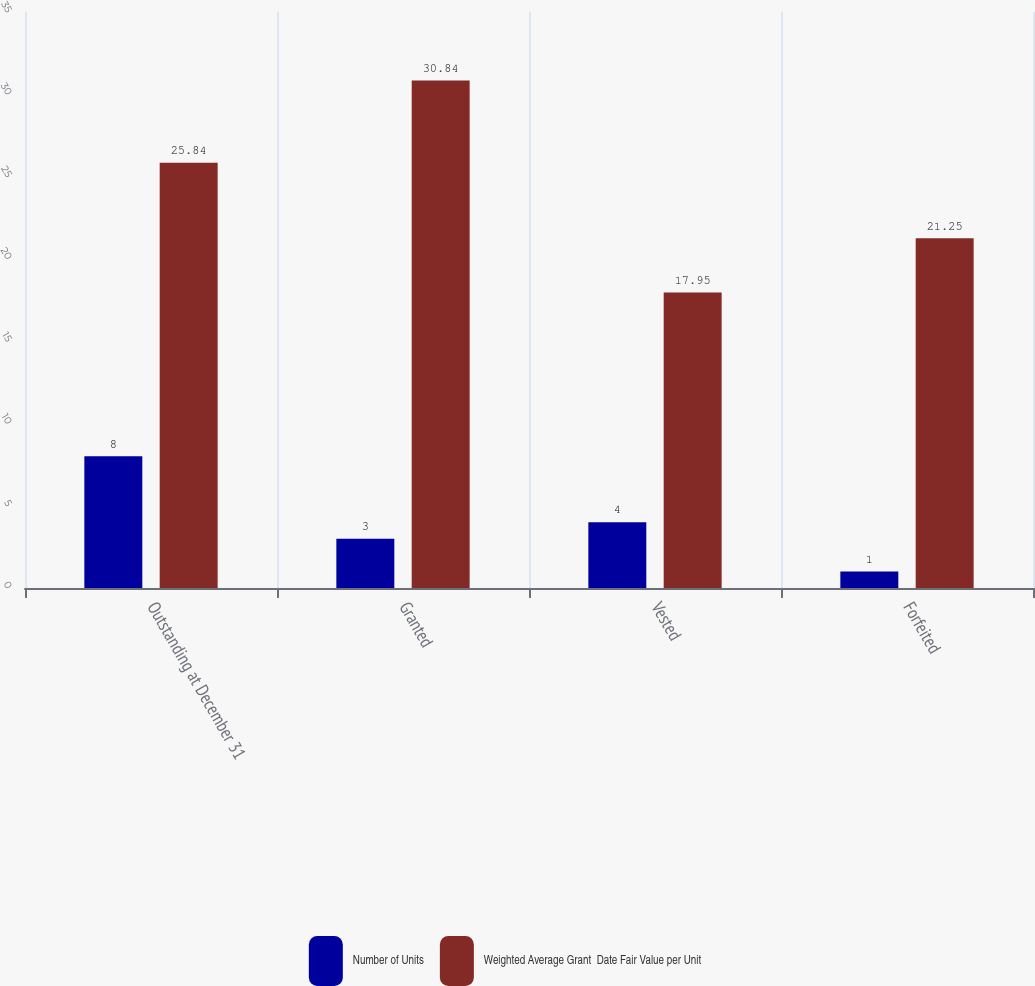Convert chart to OTSL. <chart><loc_0><loc_0><loc_500><loc_500><stacked_bar_chart><ecel><fcel>Outstanding at December 31<fcel>Granted<fcel>Vested<fcel>Forfeited<nl><fcel>Number of Units<fcel>8<fcel>3<fcel>4<fcel>1<nl><fcel>Weighted Average Grant  Date Fair Value per Unit<fcel>25.84<fcel>30.84<fcel>17.95<fcel>21.25<nl></chart> 